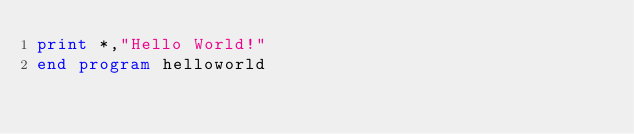<code> <loc_0><loc_0><loc_500><loc_500><_FORTRAN_>print *,"Hello World!"
end program helloworld
</code> 